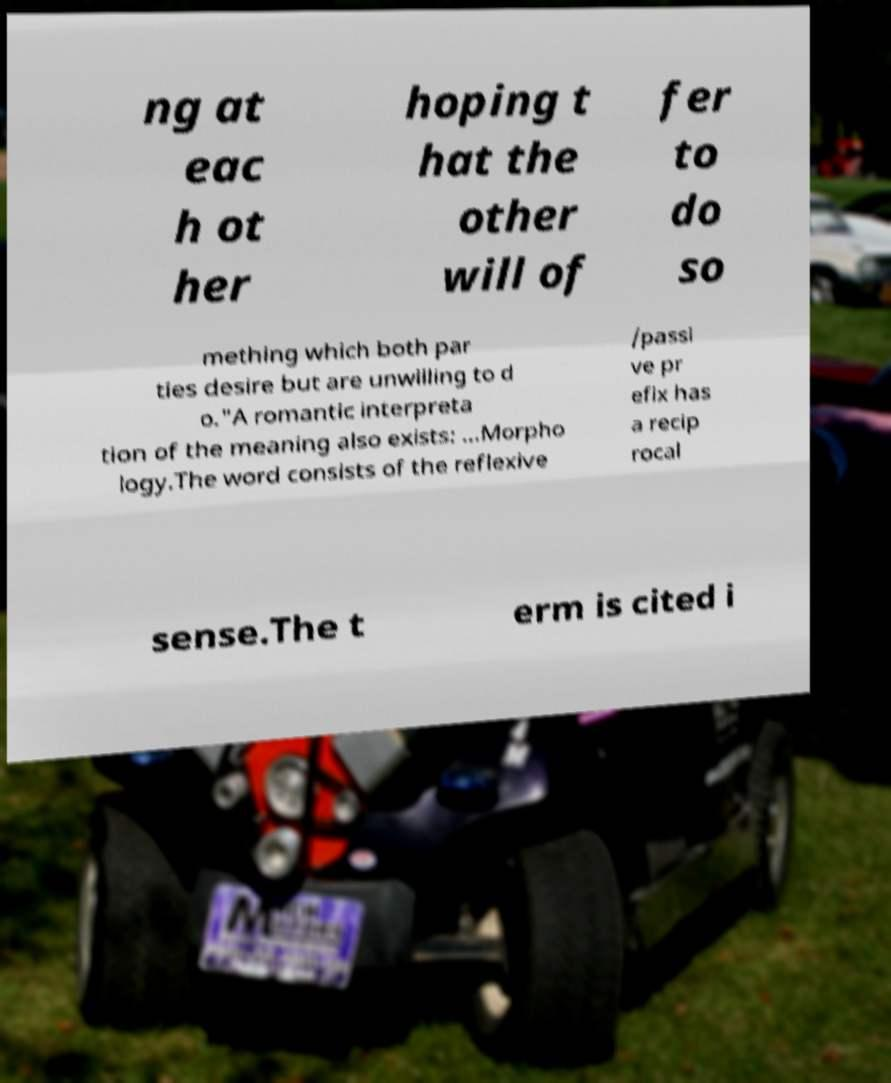There's text embedded in this image that I need extracted. Can you transcribe it verbatim? ng at eac h ot her hoping t hat the other will of fer to do so mething which both par ties desire but are unwilling to d o."A romantic interpreta tion of the meaning also exists: ...Morpho logy.The word consists of the reflexive /passi ve pr efix has a recip rocal sense.The t erm is cited i 